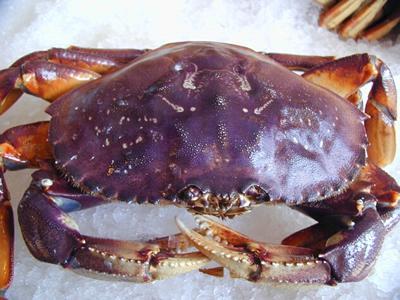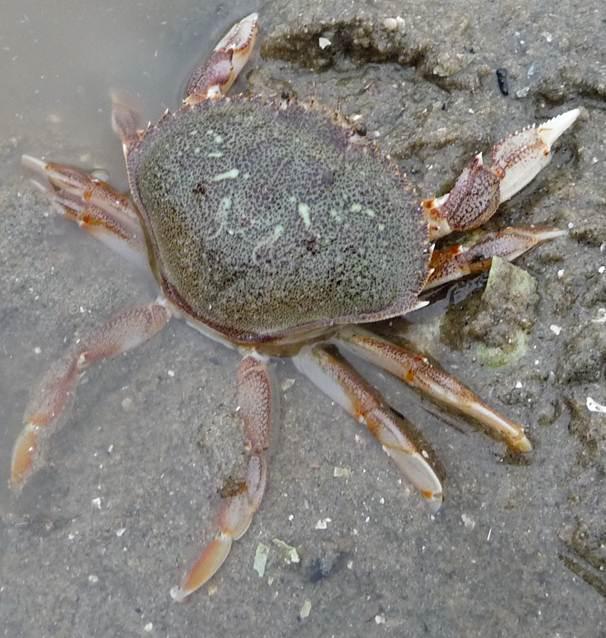The first image is the image on the left, the second image is the image on the right. Assess this claim about the two images: "One of the crabs is a shade of purple, the other is a shade of brown.". Correct or not? Answer yes or no. Yes. 